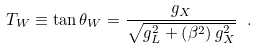Convert formula to latex. <formula><loc_0><loc_0><loc_500><loc_500>T _ { W } \equiv \tan \theta _ { W } = \frac { g _ { X } } { \sqrt { g _ { L } ^ { 2 } + \left ( \beta ^ { 2 } \right ) g _ { X } ^ { 2 } } } \ .</formula> 